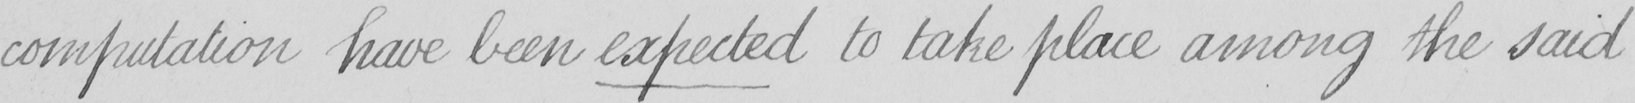Transcribe the text shown in this historical manuscript line. computation have been expected to take place among the said 